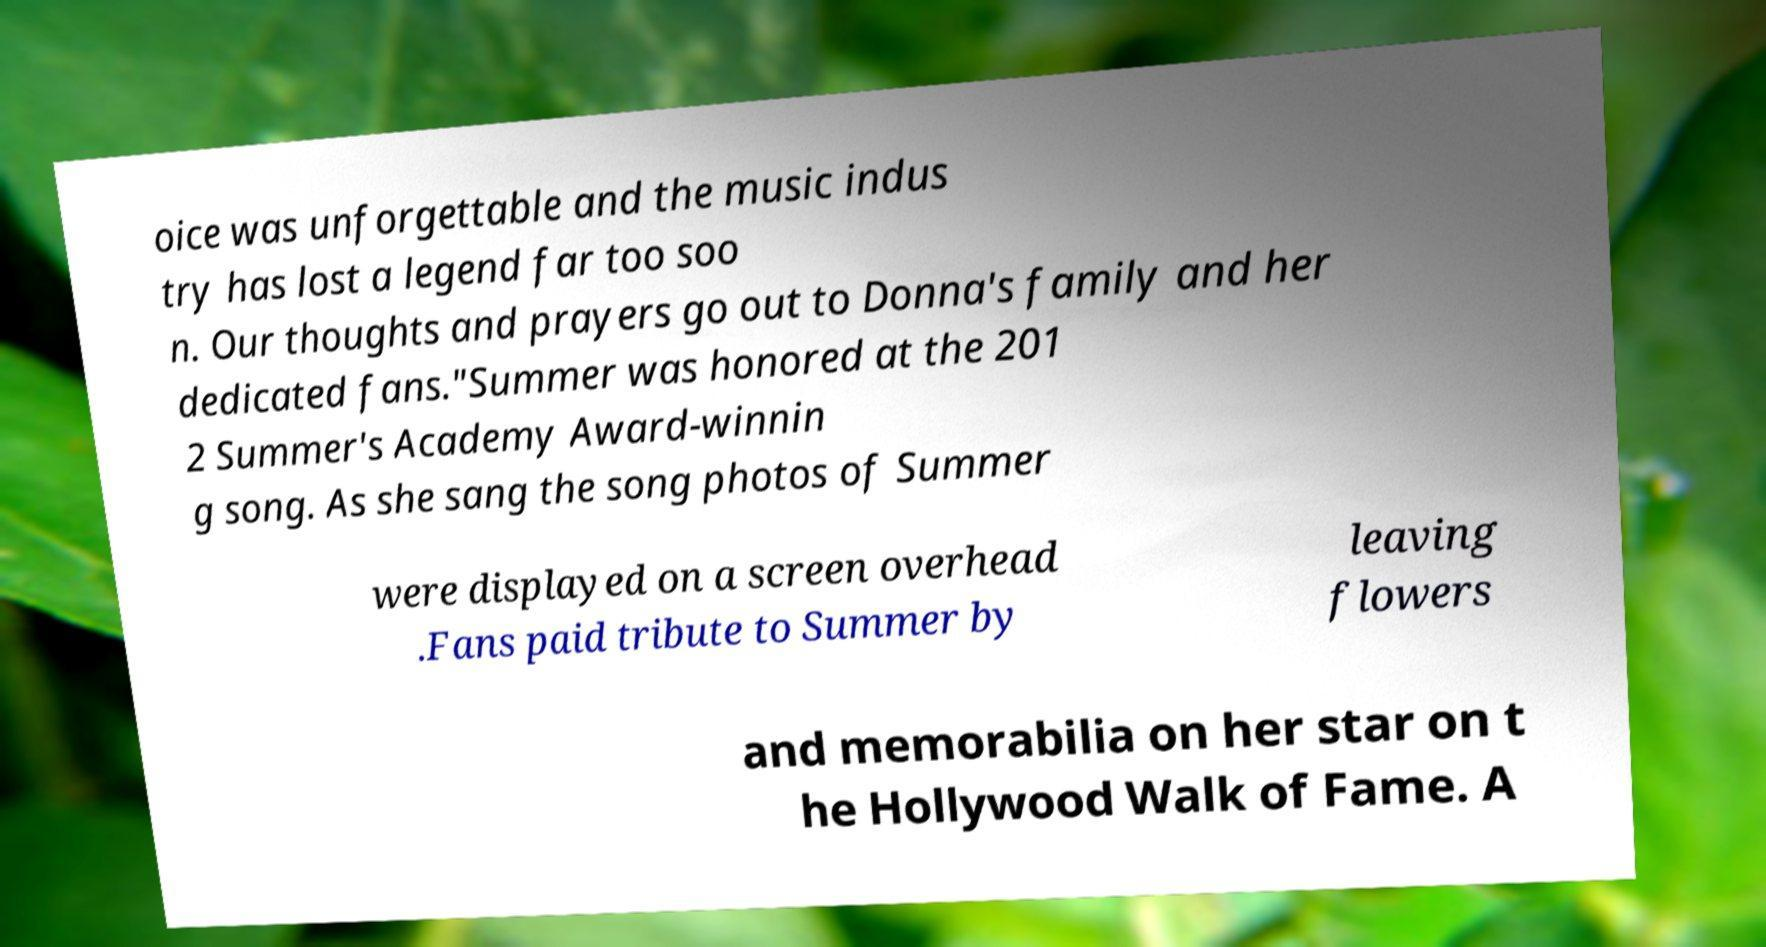Please read and relay the text visible in this image. What does it say? oice was unforgettable and the music indus try has lost a legend far too soo n. Our thoughts and prayers go out to Donna's family and her dedicated fans."Summer was honored at the 201 2 Summer's Academy Award-winnin g song. As she sang the song photos of Summer were displayed on a screen overhead .Fans paid tribute to Summer by leaving flowers and memorabilia on her star on t he Hollywood Walk of Fame. A 